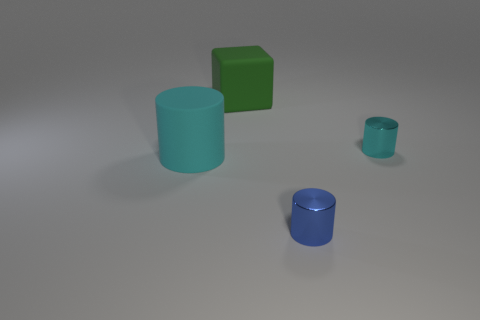Subtract all cyan cylinders. How many cylinders are left? 1 Add 1 balls. How many objects exist? 5 Subtract all blue cylinders. How many cylinders are left? 2 Subtract 0 green cylinders. How many objects are left? 4 Subtract all blocks. How many objects are left? 3 Subtract all yellow cylinders. Subtract all red cubes. How many cylinders are left? 3 Subtract all red cubes. How many red cylinders are left? 0 Subtract all large purple blocks. Subtract all tiny cyan metal cylinders. How many objects are left? 3 Add 4 large rubber cubes. How many large rubber cubes are left? 5 Add 1 small blue blocks. How many small blue blocks exist? 1 